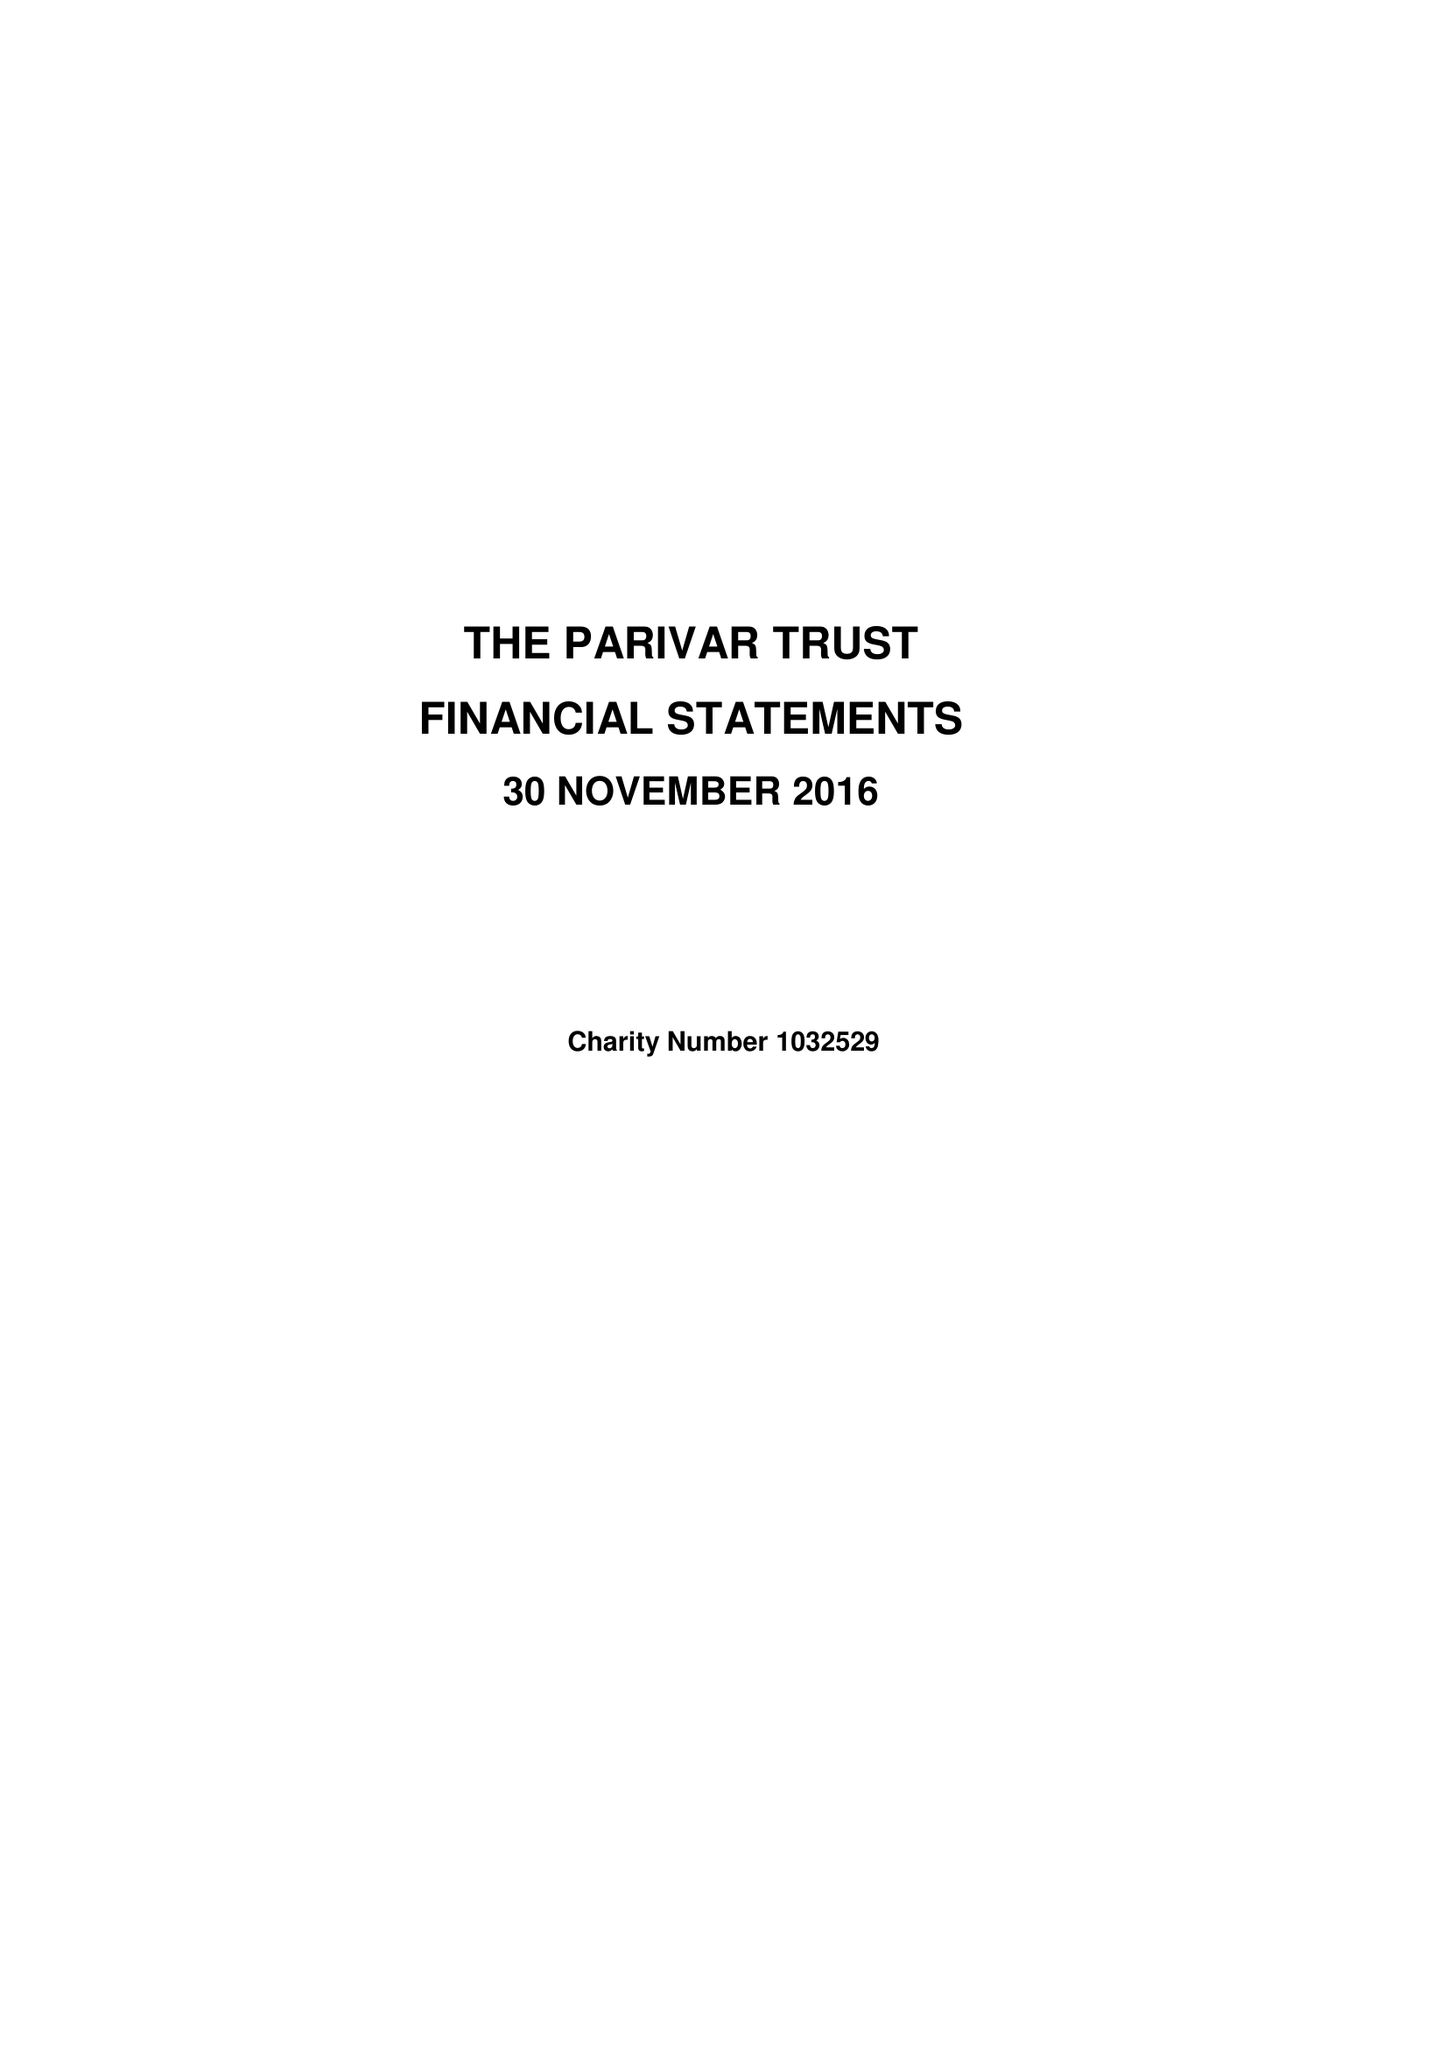What is the value for the address__postcode?
Answer the question using a single word or phrase. HR1 4SP 